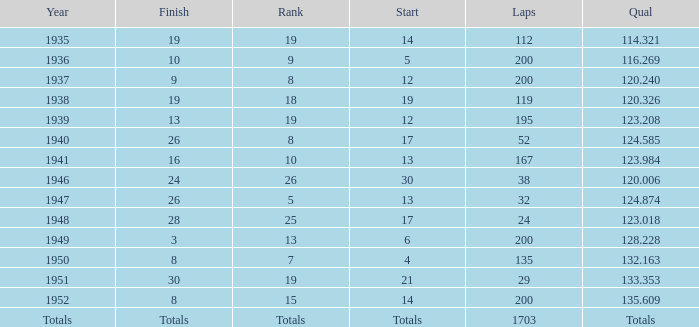The Qual of 120.006 took place in what year? 1946.0. 